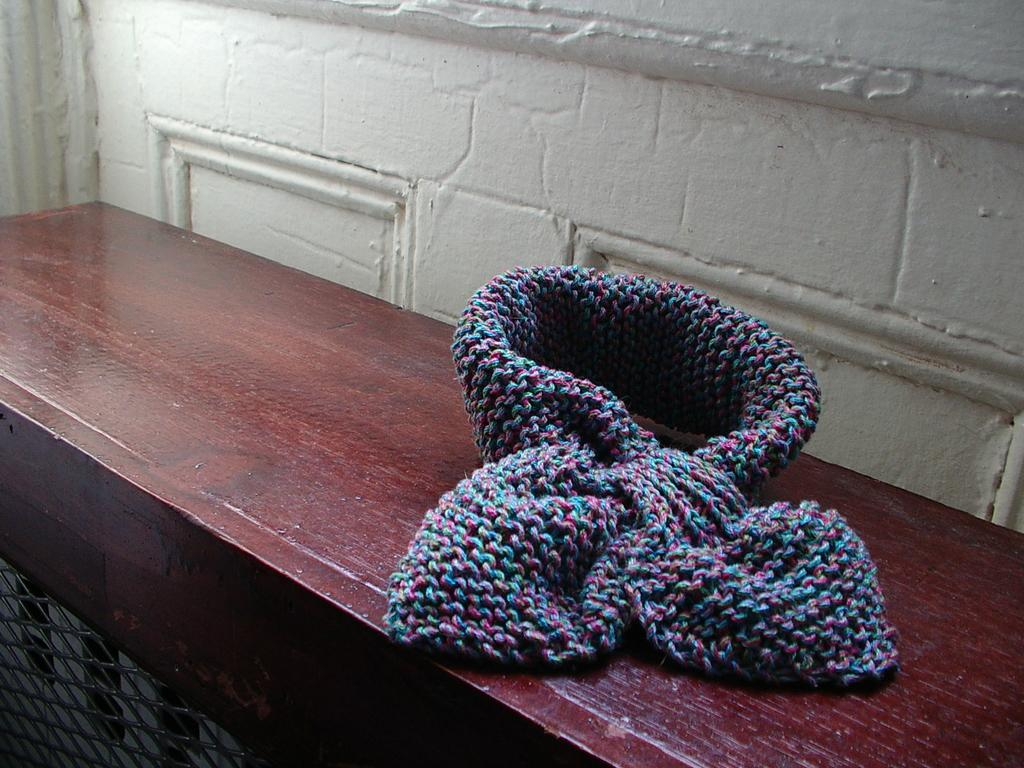What is placed on the wooden table in the image? There is a woolen scarf on the wooden table. Can you describe any other objects or features in the image? Yes, there is a mesh in the bottom left corner of the image, and a wall in the background. What type of nerve can be seen running along the wall in the image? There are no nerves visible in the image; it features a woolen scarf on a wooden table, a mesh in the bottom left corner, and a wall in the background. 